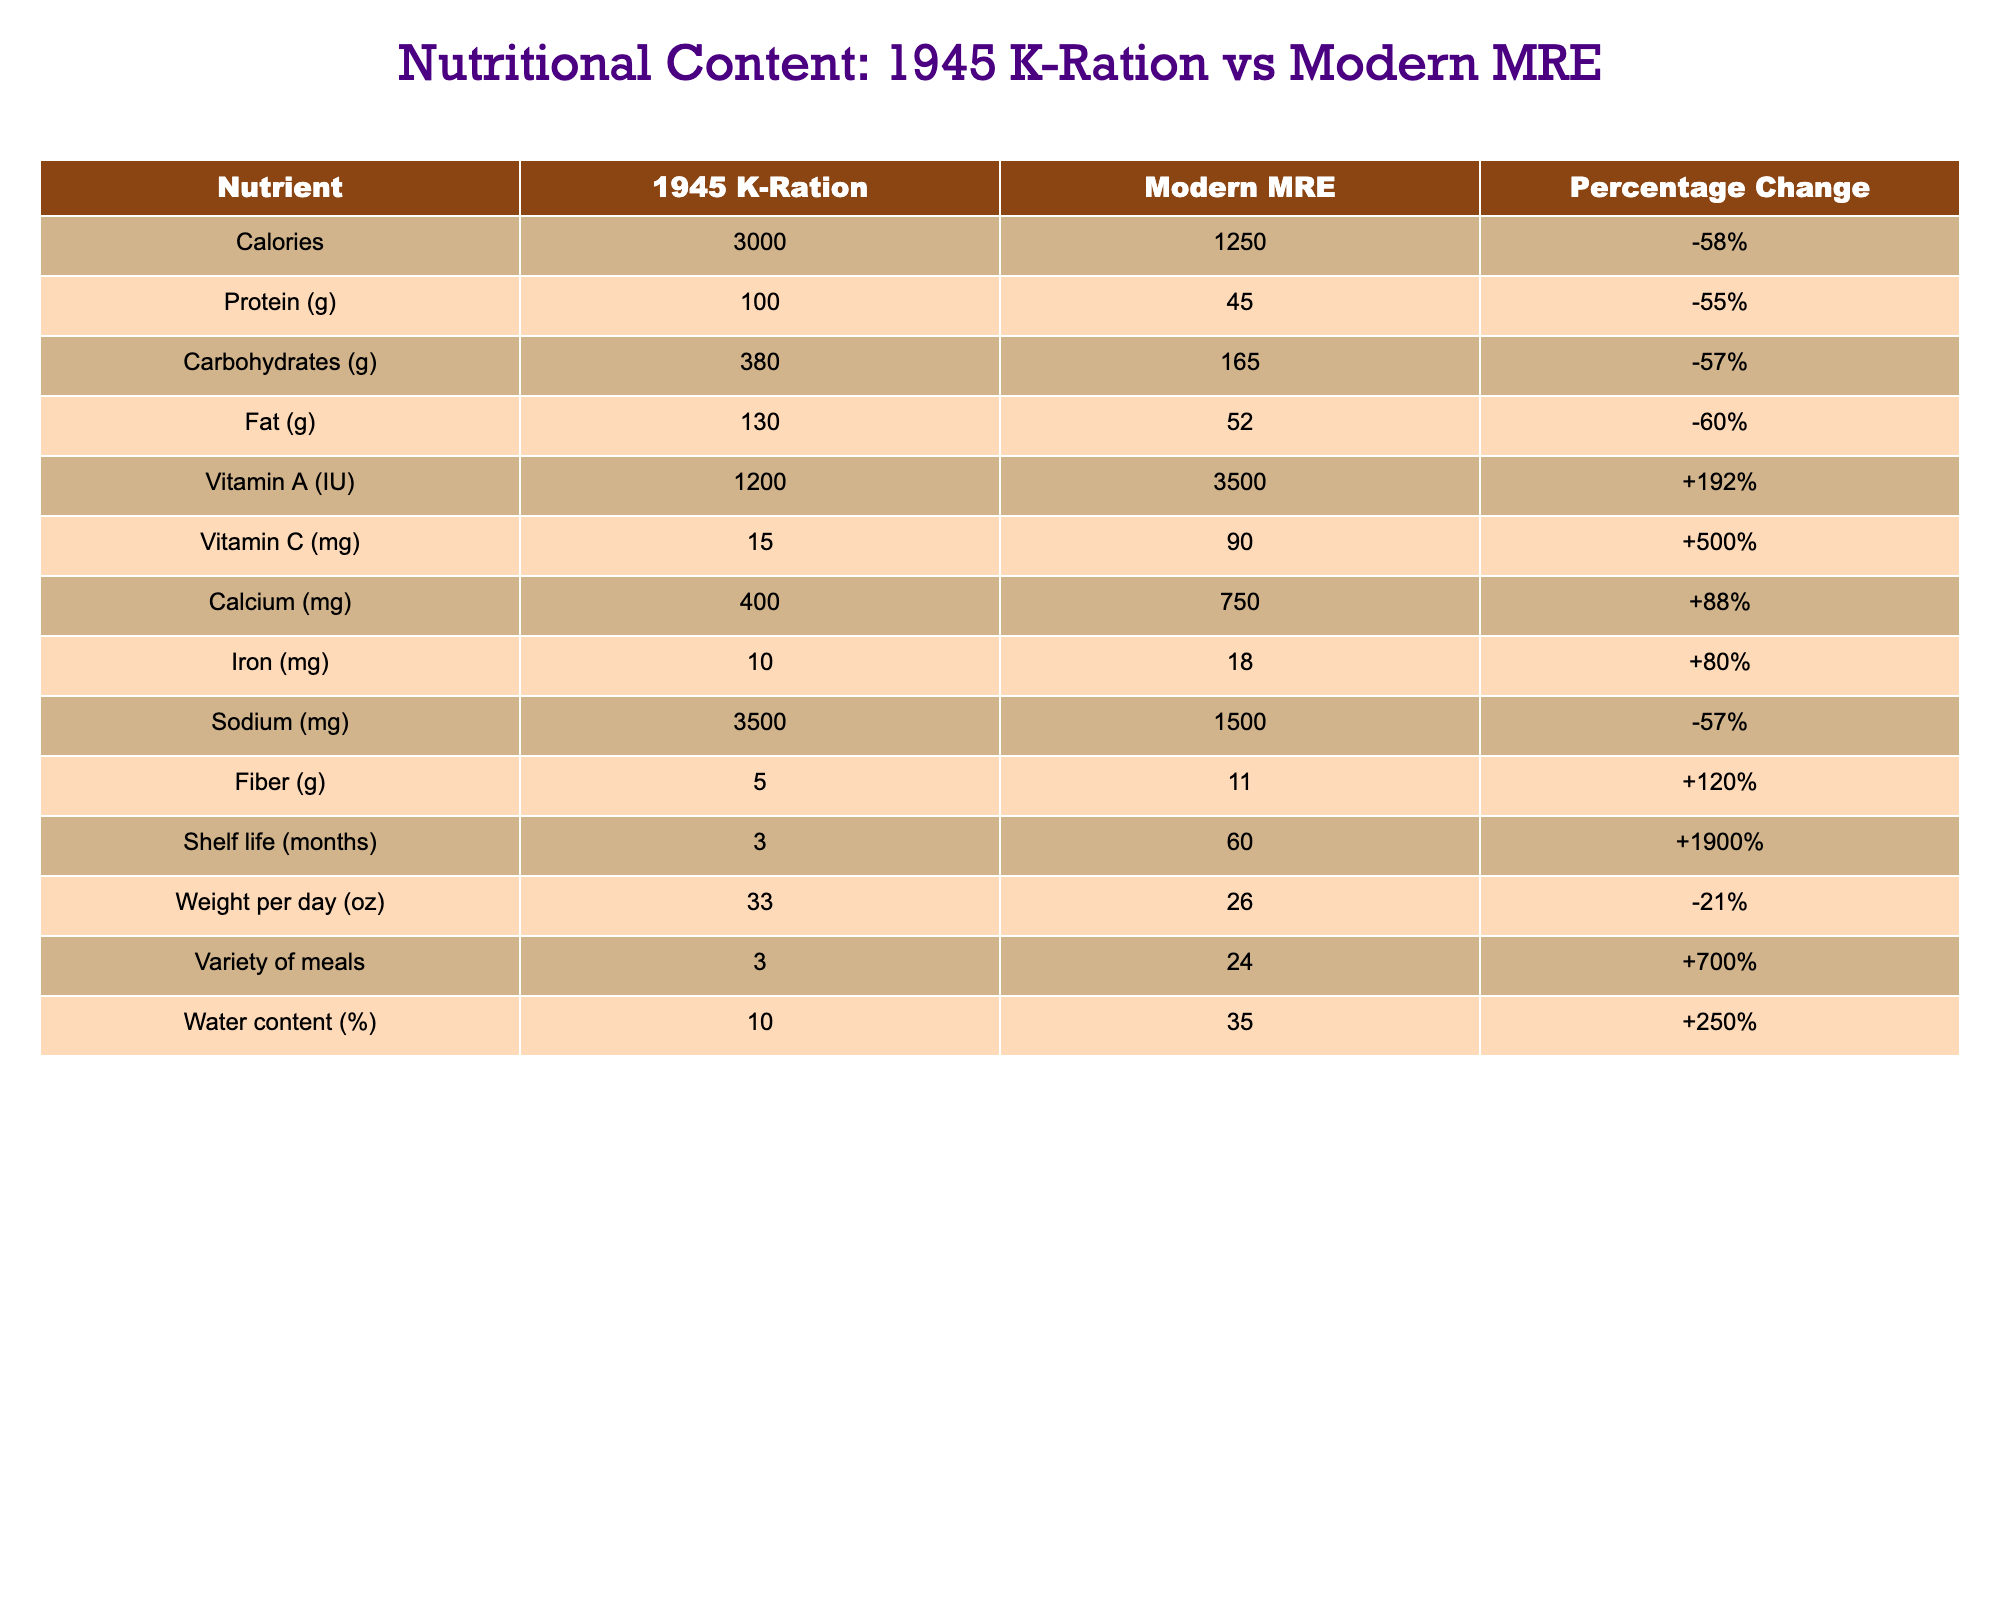What is the calorie count of the 1945 K-Ration? The table shows that the calorie count for the 1945 K-Ration is listed directly under the "1945 K-Ration" column for Calories, which is 3000.
Answer: 3000 Which nutrient has the highest percentage change in the table? By comparing the percentage change values in the last column, the highest percentage change is for Shelf life, which increased by +1900%.
Answer: Shelf life What is the total weight per day difference between the 1945 K-Ration and Modern MRE? The weight per day for the 1945 K-Ration is 33 oz and for the Modern MRE is 26 oz. The difference is calculated as 33 - 26 = 7 oz.
Answer: 7 oz Is the sodium content in Modern MRE lower than in the 1945 K-Ration? Looking at the sodium content, 3500 mg for the 1945 K-Ration and 1500 mg for the Modern MRE, 1500 mg is indeed lower than 3500 mg.
Answer: Yes What is the average protein content of the two rations? The protein content for the 1945 K-Ration is 100 g and for Modern MRE is 45 g. The average is calculated as (100 + 45) / 2 = 72.5 g.
Answer: 72.5 g Which ration has a higher Vitamin C content? The Vitamin C content for the 1945 K-Ration is 15 mg and for the Modern MRE is 90 mg. Since 90 mg is greater than 15 mg, the Modern MRE has a higher content.
Answer: Modern MRE If we sum the carbohydrate and fat contents of both rations, what is the total? The carbohydrate content for the 1945 K-Ration is 380 g and for Modern MRE it is 165 g. The fat content for 1945 K-Ration is 130 g and for Modern MRE is 52 g. The total is calculated as (380 + 165 + 130 + 52) = 727 g.
Answer: 727 g What percentage change in fiber content did the Modern MRE achieve compared to the 1945 K-Ration? The fiber content for the 1945 K-Ration is 5 g and for Modern MRE it's 11 g. The percentage change is calculated as ((11 - 5) / 5) * 100 = 120%.
Answer: 120% Has the variety of meals available increased or decreased in the Modern MRE compared to the 1945 K-Ration? The variety of meals is 3 for the 1945 K-Ration and 24 for the Modern MRE. Since 24 is greater than 3, it has increased.
Answer: Increased What is the combined calcium content in both the 1945 K-Ration and Modern MRE? The calcium for the 1945 K-Ration is 400 mg and for the Modern MRE is 750 mg. The combined total is calculated as 400 + 750 = 1150 mg.
Answer: 1150 mg 